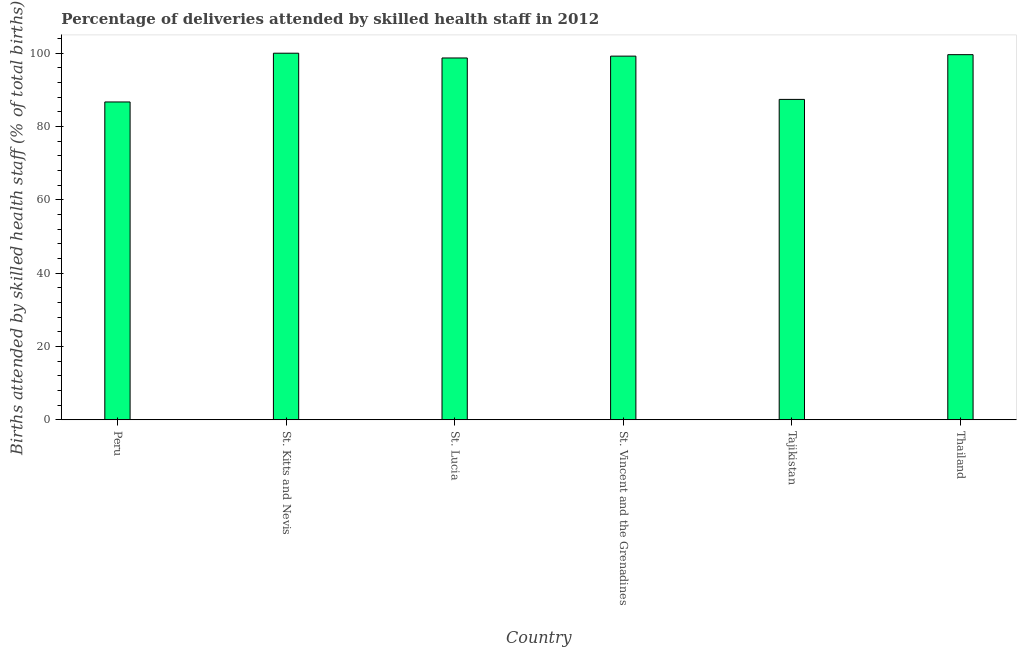Does the graph contain any zero values?
Ensure brevity in your answer.  No. Does the graph contain grids?
Keep it short and to the point. No. What is the title of the graph?
Provide a succinct answer. Percentage of deliveries attended by skilled health staff in 2012. What is the label or title of the Y-axis?
Offer a very short reply. Births attended by skilled health staff (% of total births). What is the number of births attended by skilled health staff in St. Lucia?
Keep it short and to the point. 98.7. Across all countries, what is the minimum number of births attended by skilled health staff?
Ensure brevity in your answer.  86.7. In which country was the number of births attended by skilled health staff maximum?
Offer a very short reply. St. Kitts and Nevis. What is the sum of the number of births attended by skilled health staff?
Give a very brief answer. 571.6. What is the difference between the number of births attended by skilled health staff in St. Lucia and Thailand?
Offer a terse response. -0.9. What is the average number of births attended by skilled health staff per country?
Ensure brevity in your answer.  95.27. What is the median number of births attended by skilled health staff?
Your answer should be compact. 98.95. In how many countries, is the number of births attended by skilled health staff greater than 48 %?
Give a very brief answer. 6. What is the difference between the highest and the second highest number of births attended by skilled health staff?
Your answer should be very brief. 0.4. Is the sum of the number of births attended by skilled health staff in St. Kitts and Nevis and Thailand greater than the maximum number of births attended by skilled health staff across all countries?
Provide a succinct answer. Yes. What is the difference between the highest and the lowest number of births attended by skilled health staff?
Your answer should be very brief. 13.3. How many countries are there in the graph?
Your response must be concise. 6. What is the Births attended by skilled health staff (% of total births) of Peru?
Make the answer very short. 86.7. What is the Births attended by skilled health staff (% of total births) in St. Kitts and Nevis?
Provide a succinct answer. 100. What is the Births attended by skilled health staff (% of total births) in St. Lucia?
Your answer should be compact. 98.7. What is the Births attended by skilled health staff (% of total births) of St. Vincent and the Grenadines?
Ensure brevity in your answer.  99.2. What is the Births attended by skilled health staff (% of total births) in Tajikistan?
Make the answer very short. 87.4. What is the Births attended by skilled health staff (% of total births) of Thailand?
Give a very brief answer. 99.6. What is the difference between the Births attended by skilled health staff (% of total births) in Peru and St. Lucia?
Your answer should be compact. -12. What is the difference between the Births attended by skilled health staff (% of total births) in Peru and Tajikistan?
Offer a terse response. -0.7. What is the difference between the Births attended by skilled health staff (% of total births) in St. Kitts and Nevis and Tajikistan?
Ensure brevity in your answer.  12.6. What is the difference between the Births attended by skilled health staff (% of total births) in St. Kitts and Nevis and Thailand?
Offer a terse response. 0.4. What is the difference between the Births attended by skilled health staff (% of total births) in St. Lucia and St. Vincent and the Grenadines?
Your answer should be compact. -0.5. What is the difference between the Births attended by skilled health staff (% of total births) in St. Lucia and Thailand?
Give a very brief answer. -0.9. What is the difference between the Births attended by skilled health staff (% of total births) in St. Vincent and the Grenadines and Tajikistan?
Your response must be concise. 11.8. What is the difference between the Births attended by skilled health staff (% of total births) in St. Vincent and the Grenadines and Thailand?
Give a very brief answer. -0.4. What is the ratio of the Births attended by skilled health staff (% of total births) in Peru to that in St. Kitts and Nevis?
Offer a very short reply. 0.87. What is the ratio of the Births attended by skilled health staff (% of total births) in Peru to that in St. Lucia?
Provide a short and direct response. 0.88. What is the ratio of the Births attended by skilled health staff (% of total births) in Peru to that in St. Vincent and the Grenadines?
Offer a terse response. 0.87. What is the ratio of the Births attended by skilled health staff (% of total births) in Peru to that in Thailand?
Offer a very short reply. 0.87. What is the ratio of the Births attended by skilled health staff (% of total births) in St. Kitts and Nevis to that in St. Lucia?
Provide a short and direct response. 1.01. What is the ratio of the Births attended by skilled health staff (% of total births) in St. Kitts and Nevis to that in St. Vincent and the Grenadines?
Offer a terse response. 1.01. What is the ratio of the Births attended by skilled health staff (% of total births) in St. Kitts and Nevis to that in Tajikistan?
Provide a succinct answer. 1.14. What is the ratio of the Births attended by skilled health staff (% of total births) in St. Kitts and Nevis to that in Thailand?
Your answer should be compact. 1. What is the ratio of the Births attended by skilled health staff (% of total births) in St. Lucia to that in Tajikistan?
Provide a short and direct response. 1.13. What is the ratio of the Births attended by skilled health staff (% of total births) in St. Lucia to that in Thailand?
Your response must be concise. 0.99. What is the ratio of the Births attended by skilled health staff (% of total births) in St. Vincent and the Grenadines to that in Tajikistan?
Your answer should be compact. 1.14. What is the ratio of the Births attended by skilled health staff (% of total births) in St. Vincent and the Grenadines to that in Thailand?
Provide a short and direct response. 1. What is the ratio of the Births attended by skilled health staff (% of total births) in Tajikistan to that in Thailand?
Make the answer very short. 0.88. 